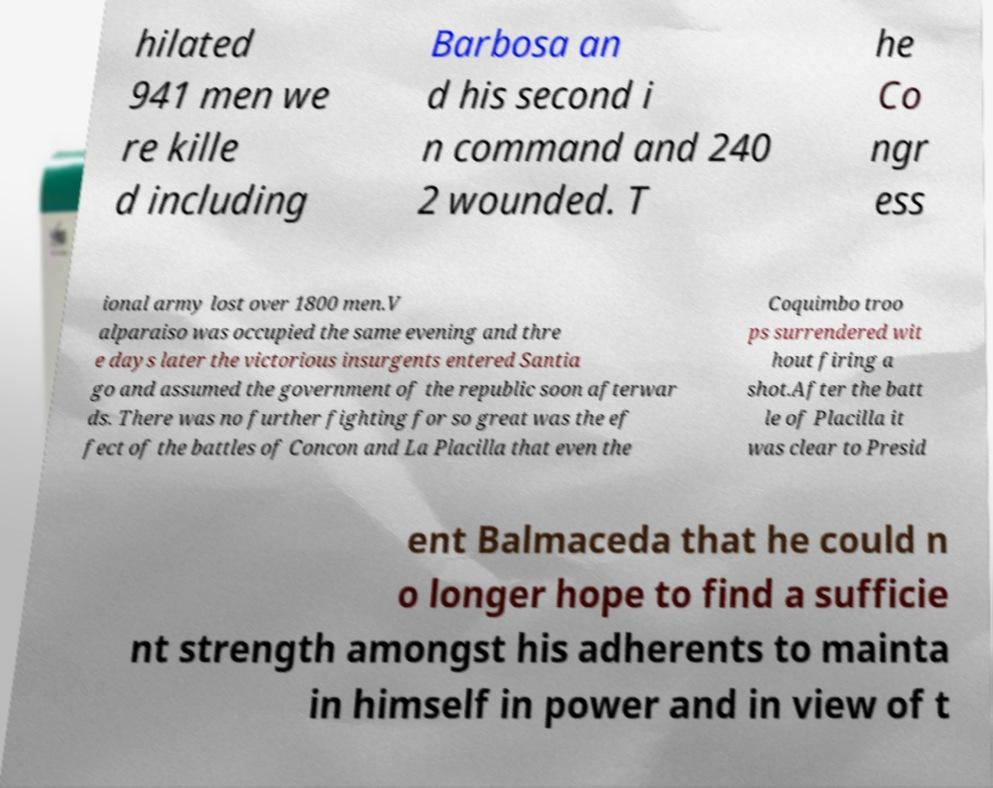I need the written content from this picture converted into text. Can you do that? hilated 941 men we re kille d including Barbosa an d his second i n command and 240 2 wounded. T he Co ngr ess ional army lost over 1800 men.V alparaiso was occupied the same evening and thre e days later the victorious insurgents entered Santia go and assumed the government of the republic soon afterwar ds. There was no further fighting for so great was the ef fect of the battles of Concon and La Placilla that even the Coquimbo troo ps surrendered wit hout firing a shot.After the batt le of Placilla it was clear to Presid ent Balmaceda that he could n o longer hope to find a sufficie nt strength amongst his adherents to mainta in himself in power and in view of t 